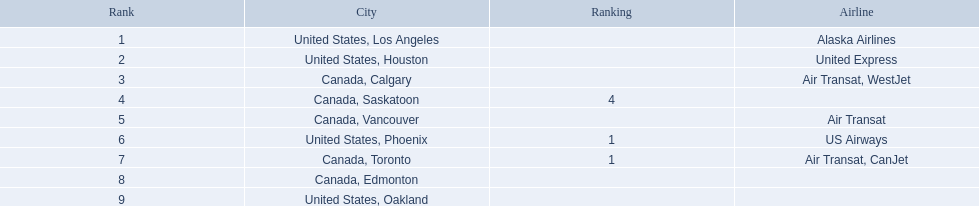What are the cities that are associated with the playa de oro international airport? United States, Los Angeles, United States, Houston, Canada, Calgary, Canada, Saskatoon, Canada, Vancouver, United States, Phoenix, Canada, Toronto, Canada, Edmonton, United States, Oakland. What is uniteed states, los angeles passenger count? 14,749. What other cities passenger count would lead to 19,000 roughly when combined with previous los angeles? Canada, Calgary. 